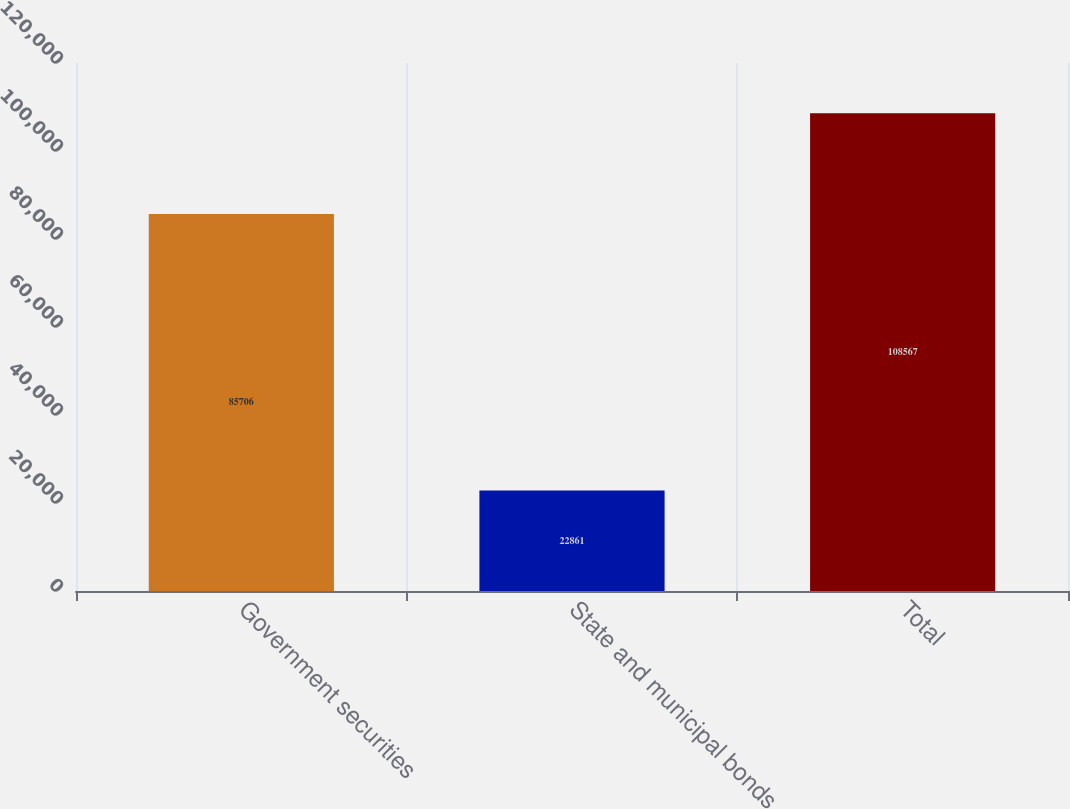<chart> <loc_0><loc_0><loc_500><loc_500><bar_chart><fcel>Government securities<fcel>State and municipal bonds<fcel>Total<nl><fcel>85706<fcel>22861<fcel>108567<nl></chart> 